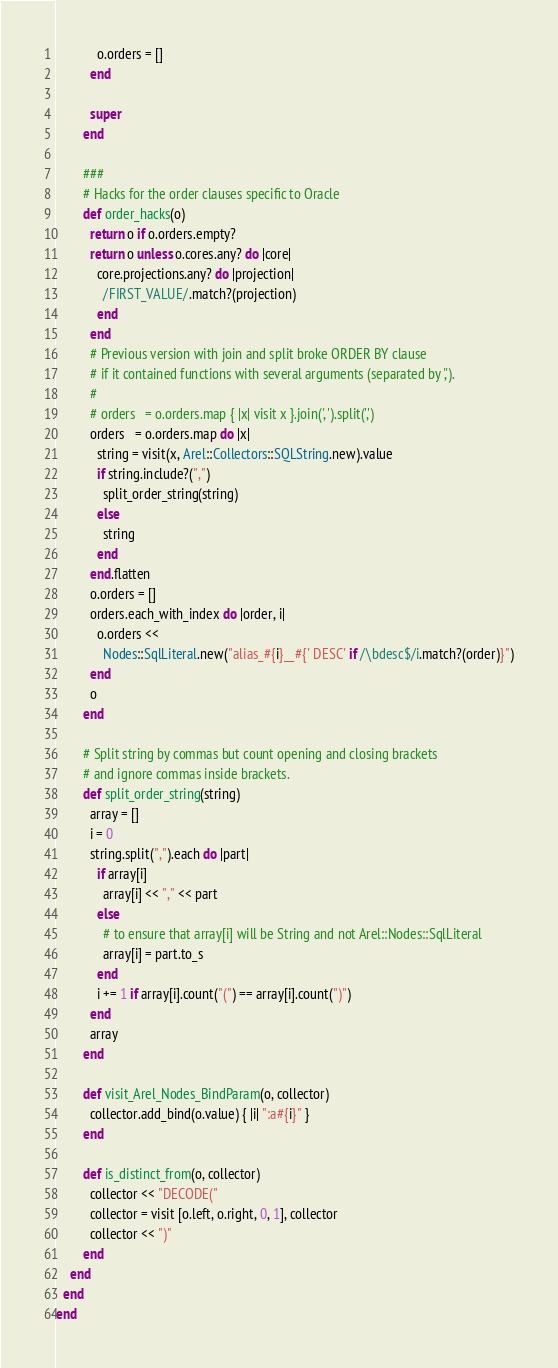Convert code to text. <code><loc_0><loc_0><loc_500><loc_500><_Ruby_>            o.orders = []
          end

          super
        end

        ###
        # Hacks for the order clauses specific to Oracle
        def order_hacks(o)
          return o if o.orders.empty?
          return o unless o.cores.any? do |core|
            core.projections.any? do |projection|
              /FIRST_VALUE/.match?(projection)
            end
          end
          # Previous version with join and split broke ORDER BY clause
          # if it contained functions with several arguments (separated by ',').
          #
          # orders   = o.orders.map { |x| visit x }.join(', ').split(',')
          orders   = o.orders.map do |x|
            string = visit(x, Arel::Collectors::SQLString.new).value
            if string.include?(",")
              split_order_string(string)
            else
              string
            end
          end.flatten
          o.orders = []
          orders.each_with_index do |order, i|
            o.orders <<
              Nodes::SqlLiteral.new("alias_#{i}__#{' DESC' if /\bdesc$/i.match?(order)}")
          end
          o
        end

        # Split string by commas but count opening and closing brackets
        # and ignore commas inside brackets.
        def split_order_string(string)
          array = []
          i = 0
          string.split(",").each do |part|
            if array[i]
              array[i] << "," << part
            else
              # to ensure that array[i] will be String and not Arel::Nodes::SqlLiteral
              array[i] = part.to_s
            end
            i += 1 if array[i].count("(") == array[i].count(")")
          end
          array
        end

        def visit_Arel_Nodes_BindParam(o, collector)
          collector.add_bind(o.value) { |i| ":a#{i}" }
        end

        def is_distinct_from(o, collector)
          collector << "DECODE("
          collector = visit [o.left, o.right, 0, 1], collector
          collector << ")"
        end
    end
  end
end
</code> 